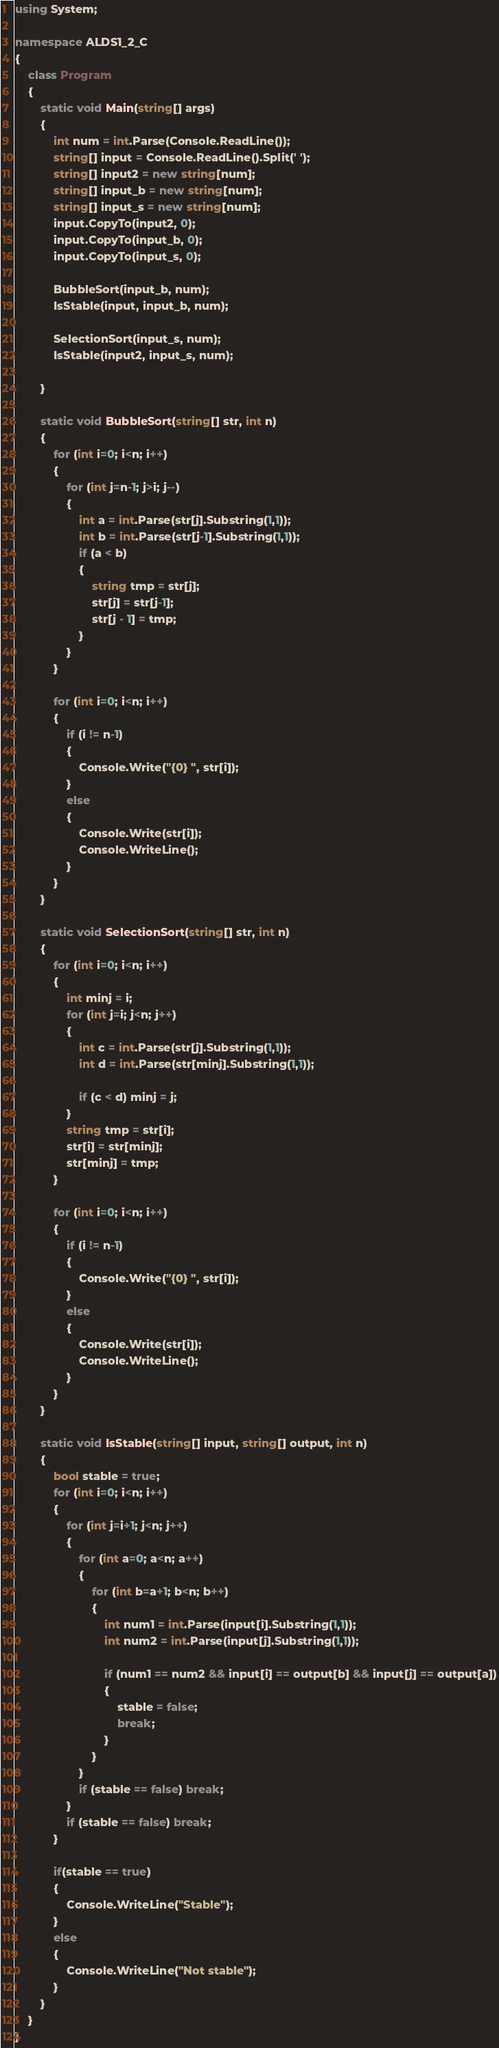<code> <loc_0><loc_0><loc_500><loc_500><_C#_>using System;

namespace ALDS1_2_C
{
    class Program
    {
        static void Main(string[] args)
        {
            int num = int.Parse(Console.ReadLine());
            string[] input = Console.ReadLine().Split(' ');
            string[] input2 = new string[num];
            string[] input_b = new string[num];
            string[] input_s = new string[num];
            input.CopyTo(input2, 0);
            input.CopyTo(input_b, 0);
            input.CopyTo(input_s, 0);
            
            BubbleSort(input_b, num);
            IsStable(input, input_b, num);
            
            SelectionSort(input_s, num);
            IsStable(input2, input_s, num);

        }

        static void BubbleSort(string[] str, int n)
        {
            for (int i=0; i<n; i++)
            {
                for (int j=n-1; j>i; j--)
                {
                    int a = int.Parse(str[j].Substring(1,1));
                    int b = int.Parse(str[j-1].Substring(1,1)); 
                    if (a < b)
                    {
                        string tmp = str[j];
                        str[j] = str[j-1];
                        str[j - 1] = tmp;
                    }
                }
            }

            for (int i=0; i<n; i++)
            {
                if (i != n-1)
                {
                    Console.Write("{0} ", str[i]);
                }
                else
                {
                    Console.Write(str[i]);
                    Console.WriteLine();
                }
            }
        }

        static void SelectionSort(string[] str, int n)
        {
            for (int i=0; i<n; i++)
            {
                int minj = i;
                for (int j=i; j<n; j++)
                {
                    int c = int.Parse(str[j].Substring(1,1));
                    int d = int.Parse(str[minj].Substring(1,1));

                    if (c < d) minj = j;
                }
                string tmp = str[i];
                str[i] = str[minj];
                str[minj] = tmp;
            }

            for (int i=0; i<n; i++)
            {
                if (i != n-1)
                {
                    Console.Write("{0} ", str[i]);
                }
                else
                {
                    Console.Write(str[i]);
                    Console.WriteLine();
                }
            }
        }

        static void IsStable(string[] input, string[] output, int n)
        {
            bool stable = true;
            for (int i=0; i<n; i++)
            {
                for (int j=i+1; j<n; j++)
                {
                    for (int a=0; a<n; a++)
                    {
                        for (int b=a+1; b<n; b++)
                        {
                            int num1 = int.Parse(input[i].Substring(1,1));
                            int num2 = int.Parse(input[j].Substring(1,1));

                            if (num1 == num2 && input[i] == output[b] && input[j] == output[a])
                            {
                                stable = false;
                                break;
                            }
                        }
                    }
                    if (stable == false) break;
                }
                if (stable == false) break;
            }

            if(stable == true)
            {
                Console.WriteLine("Stable");
            }
            else
            {
                Console.WriteLine("Not stable");
            }
        }
    }
}</code> 